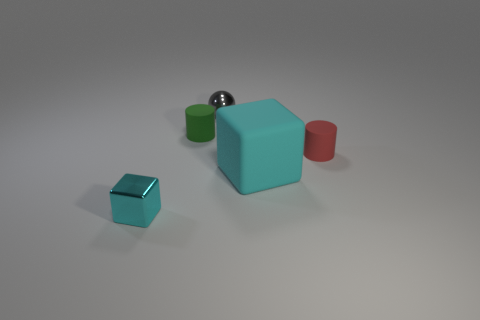Are there any brown metal cubes? Upon reviewing the image, there are no brown cubes present. Instead, the image features a variety of geometric shapes including a large teal cube, a smaller green cube, a small cyan cube, a red cylinder, and a metallic sphere. All items appear to have a smooth finish and are placed on a neutral, matte surface. 